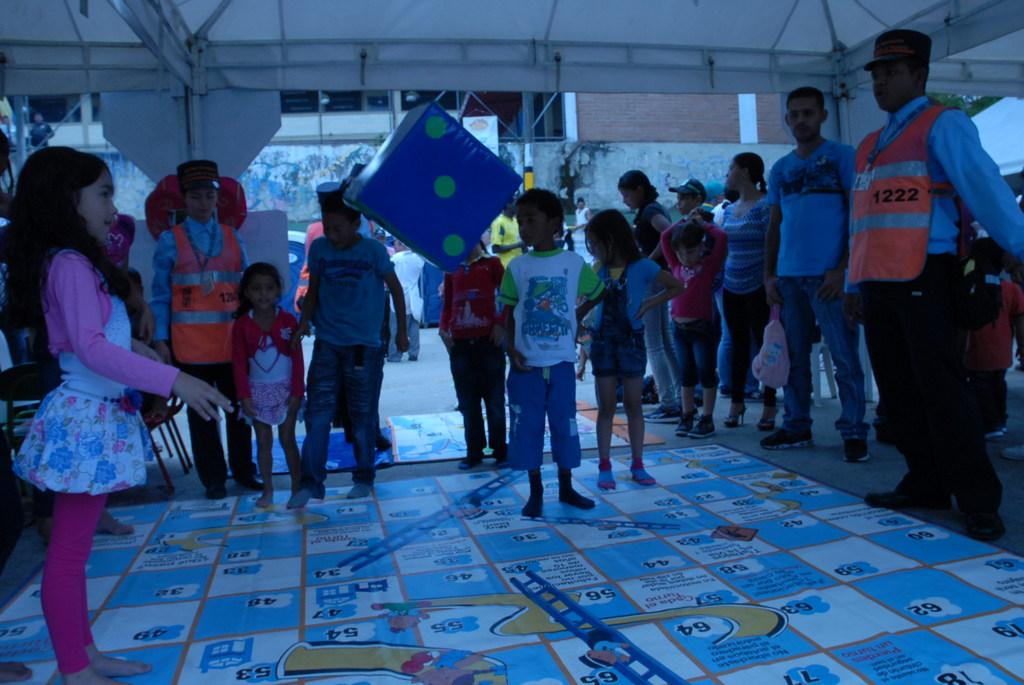What is happening with the group of people in the image? There is a group of people standing in the image. What activity is the girl engaged in? The girl is playing snake and ladder in the image. What can be seen in the distance behind the people? There are buildings visible in the background of the image. What type of linen is being used to cover the snake in the game? There is no linen present in the image, and the snake in the game is a part of the board, not a physical object that requires covering. 